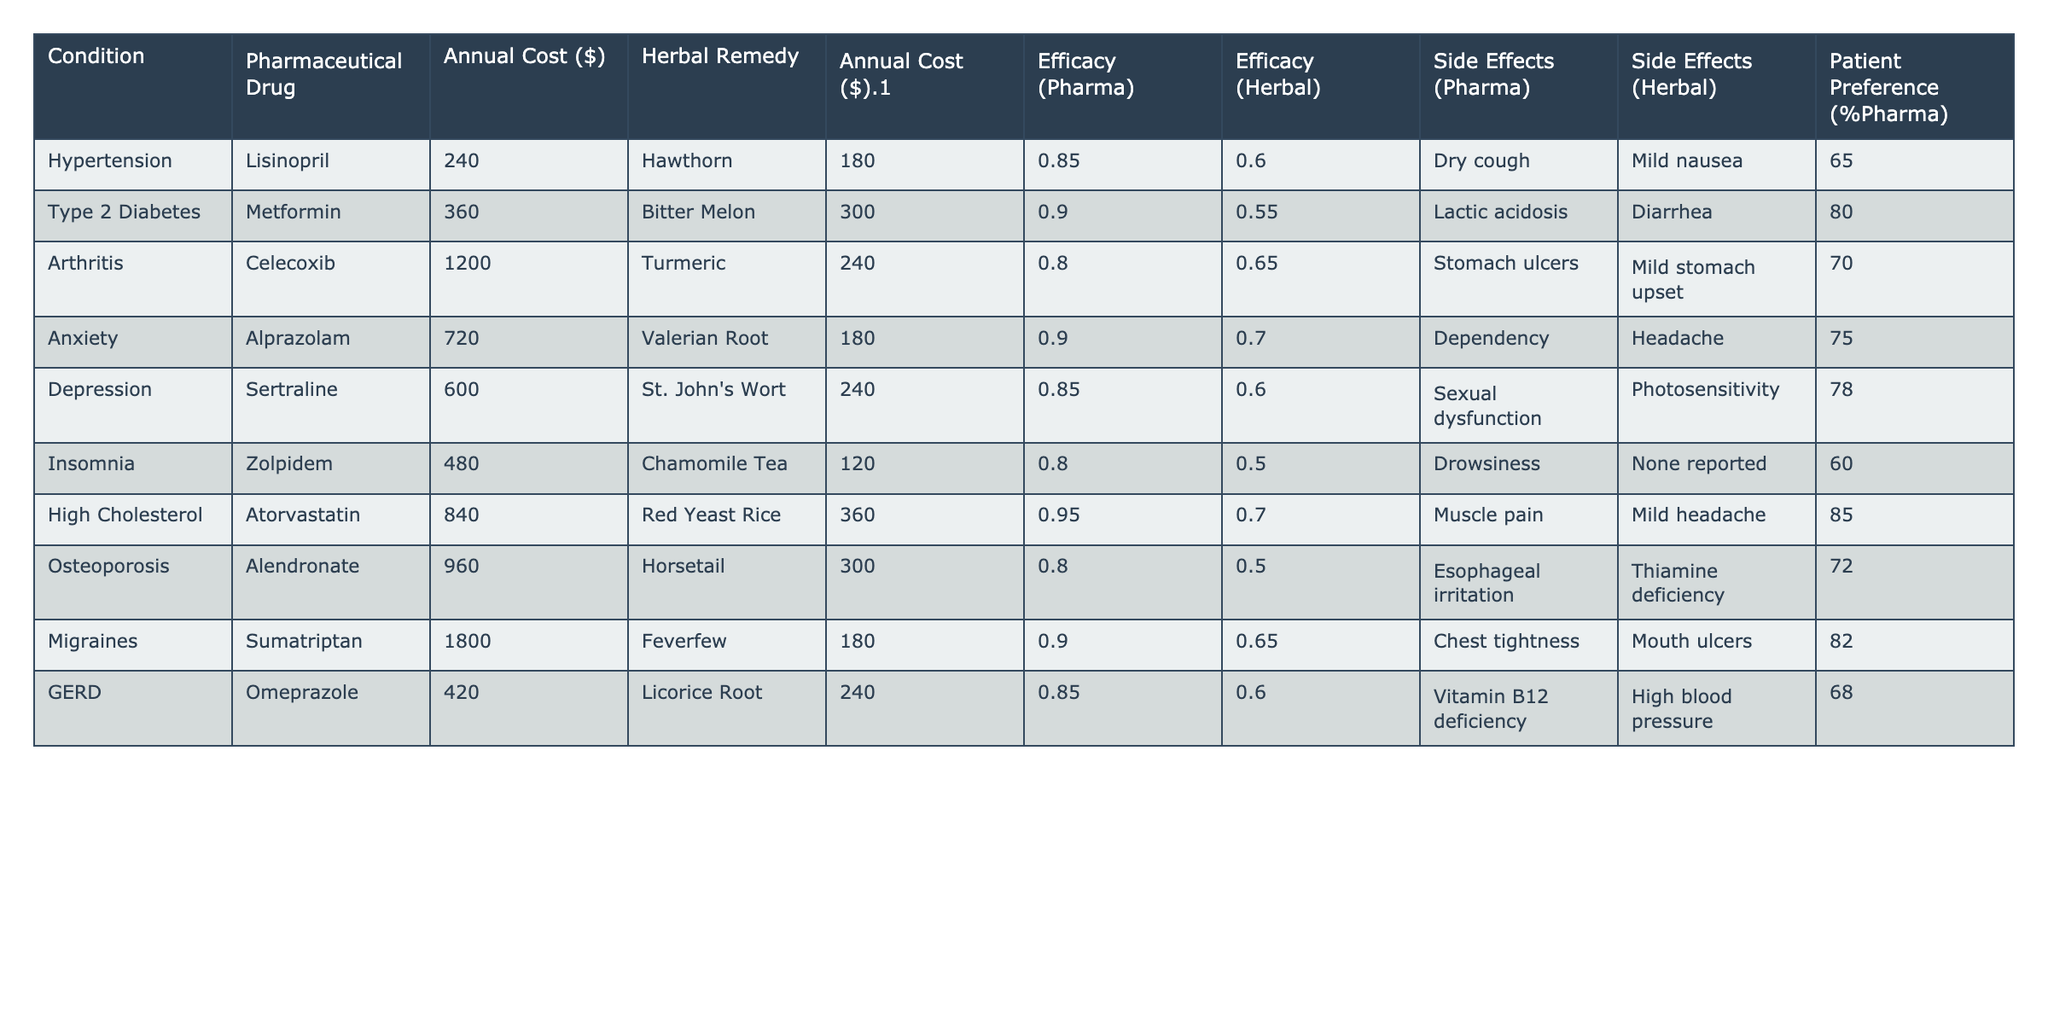What is the cost of the pharmaceutical drug for hypertension? The table indicates that the pharmaceutical drug for hypertension is Lisinopril, which has an annual cost of $240.
Answer: $240 What is the efficacy percentage of the herbal remedy for Type 2 Diabetes? According to the table, the herbal remedy for Type 2 Diabetes is Bitter Melon, which has an efficacy of 0.55 or 55%.
Answer: 55% What is the annual cost difference between Celecoxib and Turmeric for arthritis treatment? The annual cost of Celecoxib is $1200, while Turmeric costs $240. The difference is $1200 - $240 = $960.
Answer: $960 Is there a higher patient preference for pharmaceutical drugs compared to herbal remedies for anxiety? The table shows a patient preference of 75% for the pharmaceutical drug Alprazolam and 25% for the herbal remedy Valerian Root, indicating that the preference for the pharmaceutical drug is indeed higher.
Answer: Yes Which condition has the highest cost for a pharmaceutical drug? Reviewing the table, migraines treated with Sumatriptan cost $1800 annually, making it the highest cost for any pharmaceutical drug listed.
Answer: Migraines What is the average cost of the herbal remedies listed in the table? The costs of herbal remedies are: Hawthorn ($180), Bitter Melon ($300), Turmeric ($240), Valerian Root ($180), St. John's Wort ($240), Chamomile Tea ($120), Red Yeast Rice ($360), Horsetail ($300), Feverfew ($180), and Licorice Root ($240). Summing these gives 180 + 300 + 240 + 180 + 240 + 120 + 360 + 300 + 180 + 240 = $2280. Dividing by 10 (number of remedies) yields an average of $228.
Answer: $228 Which drug has a higher efficacy, Lisinopril or Hawthorn? The efficacy for Lisinopril (0.85 or 85%) is compared to the efficacy of Hawthorn (0.6 or 60%). Since 0.85 is greater than 0.6, Lisinopril has a higher efficacy.
Answer: Lisinopril What are the side effects of Metformin and their impact on patient preference? Metformin has a side effect of lactic acidosis, which can be severe, but the patient preference for it is 80%. This indicates that despite potential side effects, patient preference remains high for this drug.
Answer: Side effect: lactic acidosis; Preference: 80% How do the side effects of Celecoxib compare to those of Turmeric in terms of severity? Celecoxib has the side effect of stomach ulcers, which is considered more severe compared to Turmeric’s mild stomach upset. Therefore, overall, Celecoxib presents a higher risk concerning side effects.
Answer: Celecoxib is more severe If a patient is primarily concerned about side effects, which remedy should they choose for treating arthritis? The table indicates that Turmeric has mild stomach upset as a side effect, while Celecoxib may cause stomach ulcers, which are more severe. Therefore, a patient concerned about side effects should choose Turmeric.
Answer: Turmeric Which condition has the lowest annual cost for its herbal remedy? Looking at the table, Chamomile Tea for insomnia costs $120, which is the lowest cost among the herbal remedies.
Answer: Insomnia 